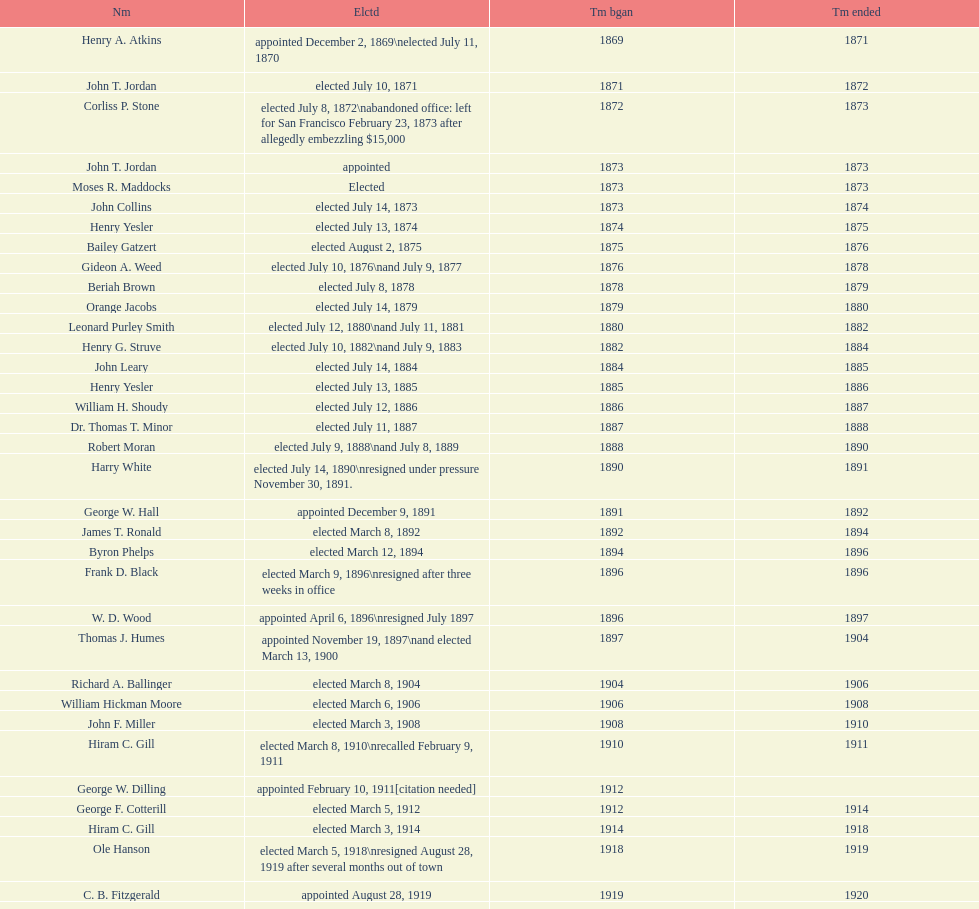What is the number of mayors with the first name of john? 6. 